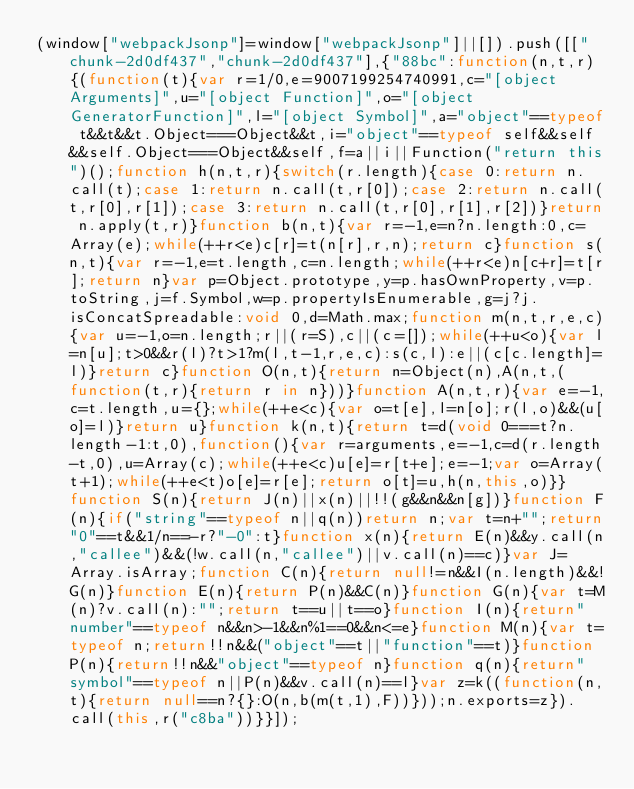Convert code to text. <code><loc_0><loc_0><loc_500><loc_500><_JavaScript_>(window["webpackJsonp"]=window["webpackJsonp"]||[]).push([["chunk-2d0df437","chunk-2d0df437"],{"88bc":function(n,t,r){(function(t){var r=1/0,e=9007199254740991,c="[object Arguments]",u="[object Function]",o="[object GeneratorFunction]",l="[object Symbol]",a="object"==typeof t&&t&&t.Object===Object&&t,i="object"==typeof self&&self&&self.Object===Object&&self,f=a||i||Function("return this")();function h(n,t,r){switch(r.length){case 0:return n.call(t);case 1:return n.call(t,r[0]);case 2:return n.call(t,r[0],r[1]);case 3:return n.call(t,r[0],r[1],r[2])}return n.apply(t,r)}function b(n,t){var r=-1,e=n?n.length:0,c=Array(e);while(++r<e)c[r]=t(n[r],r,n);return c}function s(n,t){var r=-1,e=t.length,c=n.length;while(++r<e)n[c+r]=t[r];return n}var p=Object.prototype,y=p.hasOwnProperty,v=p.toString,j=f.Symbol,w=p.propertyIsEnumerable,g=j?j.isConcatSpreadable:void 0,d=Math.max;function m(n,t,r,e,c){var u=-1,o=n.length;r||(r=S),c||(c=[]);while(++u<o){var l=n[u];t>0&&r(l)?t>1?m(l,t-1,r,e,c):s(c,l):e||(c[c.length]=l)}return c}function O(n,t){return n=Object(n),A(n,t,(function(t,r){return r in n}))}function A(n,t,r){var e=-1,c=t.length,u={};while(++e<c){var o=t[e],l=n[o];r(l,o)&&(u[o]=l)}return u}function k(n,t){return t=d(void 0===t?n.length-1:t,0),function(){var r=arguments,e=-1,c=d(r.length-t,0),u=Array(c);while(++e<c)u[e]=r[t+e];e=-1;var o=Array(t+1);while(++e<t)o[e]=r[e];return o[t]=u,h(n,this,o)}}function S(n){return J(n)||x(n)||!!(g&&n&&n[g])}function F(n){if("string"==typeof n||q(n))return n;var t=n+"";return"0"==t&&1/n==-r?"-0":t}function x(n){return E(n)&&y.call(n,"callee")&&(!w.call(n,"callee")||v.call(n)==c)}var J=Array.isArray;function C(n){return null!=n&&I(n.length)&&!G(n)}function E(n){return P(n)&&C(n)}function G(n){var t=M(n)?v.call(n):"";return t==u||t==o}function I(n){return"number"==typeof n&&n>-1&&n%1==0&&n<=e}function M(n){var t=typeof n;return!!n&&("object"==t||"function"==t)}function P(n){return!!n&&"object"==typeof n}function q(n){return"symbol"==typeof n||P(n)&&v.call(n)==l}var z=k((function(n,t){return null==n?{}:O(n,b(m(t,1),F))}));n.exports=z}).call(this,r("c8ba"))}}]);</code> 